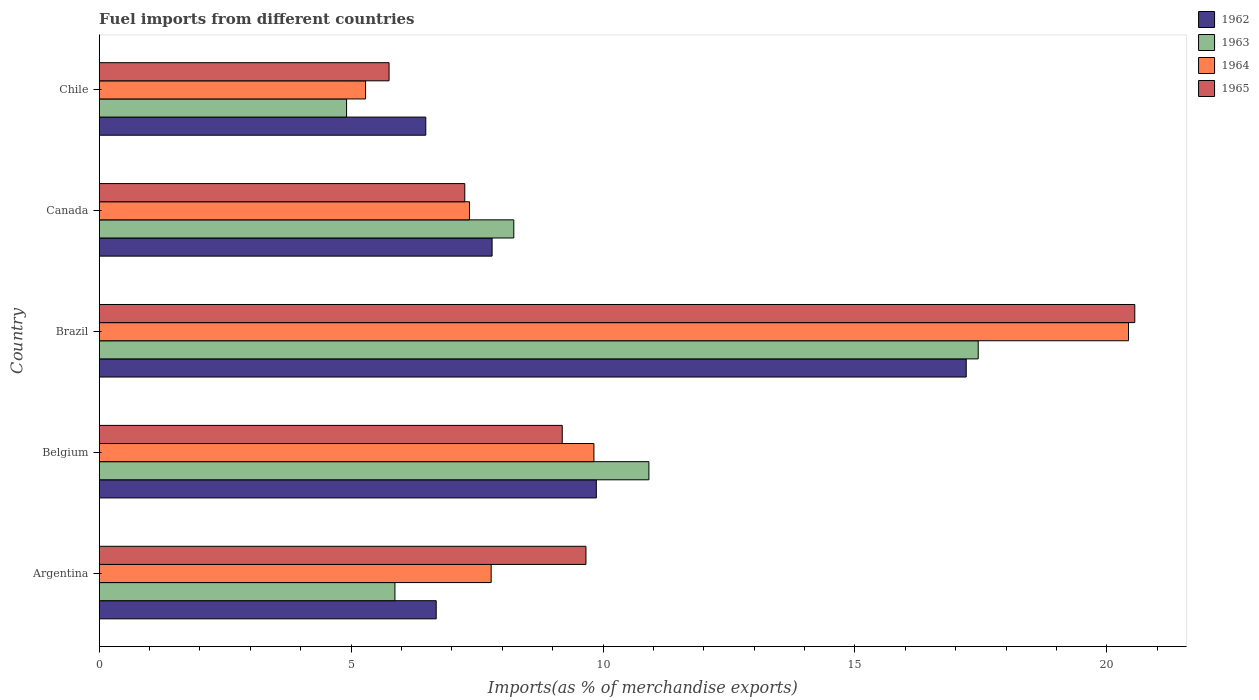How many different coloured bars are there?
Offer a very short reply. 4. How many groups of bars are there?
Offer a terse response. 5. How many bars are there on the 3rd tick from the top?
Provide a succinct answer. 4. How many bars are there on the 4th tick from the bottom?
Your answer should be compact. 4. What is the percentage of imports to different countries in 1965 in Argentina?
Provide a short and direct response. 9.66. Across all countries, what is the maximum percentage of imports to different countries in 1964?
Ensure brevity in your answer.  20.43. Across all countries, what is the minimum percentage of imports to different countries in 1962?
Provide a succinct answer. 6.48. What is the total percentage of imports to different countries in 1963 in the graph?
Your answer should be compact. 47.37. What is the difference between the percentage of imports to different countries in 1962 in Belgium and that in Chile?
Provide a short and direct response. 3.39. What is the difference between the percentage of imports to different countries in 1962 in Argentina and the percentage of imports to different countries in 1963 in Brazil?
Offer a very short reply. -10.76. What is the average percentage of imports to different countries in 1963 per country?
Offer a terse response. 9.47. What is the difference between the percentage of imports to different countries in 1964 and percentage of imports to different countries in 1963 in Chile?
Offer a very short reply. 0.38. In how many countries, is the percentage of imports to different countries in 1965 greater than 12 %?
Ensure brevity in your answer.  1. What is the ratio of the percentage of imports to different countries in 1964 in Belgium to that in Brazil?
Your response must be concise. 0.48. Is the percentage of imports to different countries in 1962 in Brazil less than that in Canada?
Ensure brevity in your answer.  No. Is the difference between the percentage of imports to different countries in 1964 in Argentina and Chile greater than the difference between the percentage of imports to different countries in 1963 in Argentina and Chile?
Ensure brevity in your answer.  Yes. What is the difference between the highest and the second highest percentage of imports to different countries in 1964?
Your response must be concise. 10.61. What is the difference between the highest and the lowest percentage of imports to different countries in 1964?
Offer a very short reply. 15.14. Is it the case that in every country, the sum of the percentage of imports to different countries in 1963 and percentage of imports to different countries in 1965 is greater than the sum of percentage of imports to different countries in 1964 and percentage of imports to different countries in 1962?
Offer a very short reply. No. What does the 3rd bar from the bottom in Belgium represents?
Provide a succinct answer. 1964. Is it the case that in every country, the sum of the percentage of imports to different countries in 1964 and percentage of imports to different countries in 1962 is greater than the percentage of imports to different countries in 1963?
Provide a succinct answer. Yes. How many bars are there?
Give a very brief answer. 20. Are all the bars in the graph horizontal?
Your answer should be compact. Yes. How many countries are there in the graph?
Offer a terse response. 5. Does the graph contain grids?
Make the answer very short. No. How many legend labels are there?
Offer a very short reply. 4. What is the title of the graph?
Make the answer very short. Fuel imports from different countries. What is the label or title of the X-axis?
Your answer should be very brief. Imports(as % of merchandise exports). What is the Imports(as % of merchandise exports) in 1962 in Argentina?
Offer a very short reply. 6.69. What is the Imports(as % of merchandise exports) in 1963 in Argentina?
Offer a very short reply. 5.87. What is the Imports(as % of merchandise exports) in 1964 in Argentina?
Your response must be concise. 7.78. What is the Imports(as % of merchandise exports) of 1965 in Argentina?
Your response must be concise. 9.66. What is the Imports(as % of merchandise exports) in 1962 in Belgium?
Your response must be concise. 9.87. What is the Imports(as % of merchandise exports) in 1963 in Belgium?
Keep it short and to the point. 10.91. What is the Imports(as % of merchandise exports) of 1964 in Belgium?
Make the answer very short. 9.82. What is the Imports(as % of merchandise exports) in 1965 in Belgium?
Provide a succinct answer. 9.19. What is the Imports(as % of merchandise exports) of 1962 in Brazil?
Provide a short and direct response. 17.21. What is the Imports(as % of merchandise exports) in 1963 in Brazil?
Your answer should be very brief. 17.45. What is the Imports(as % of merchandise exports) in 1964 in Brazil?
Offer a terse response. 20.43. What is the Imports(as % of merchandise exports) in 1965 in Brazil?
Provide a succinct answer. 20.55. What is the Imports(as % of merchandise exports) in 1962 in Canada?
Ensure brevity in your answer.  7.8. What is the Imports(as % of merchandise exports) in 1963 in Canada?
Offer a terse response. 8.23. What is the Imports(as % of merchandise exports) in 1964 in Canada?
Your answer should be very brief. 7.35. What is the Imports(as % of merchandise exports) in 1965 in Canada?
Offer a terse response. 7.26. What is the Imports(as % of merchandise exports) of 1962 in Chile?
Give a very brief answer. 6.48. What is the Imports(as % of merchandise exports) of 1963 in Chile?
Offer a terse response. 4.91. What is the Imports(as % of merchandise exports) in 1964 in Chile?
Offer a very short reply. 5.29. What is the Imports(as % of merchandise exports) of 1965 in Chile?
Make the answer very short. 5.75. Across all countries, what is the maximum Imports(as % of merchandise exports) of 1962?
Your answer should be compact. 17.21. Across all countries, what is the maximum Imports(as % of merchandise exports) in 1963?
Keep it short and to the point. 17.45. Across all countries, what is the maximum Imports(as % of merchandise exports) in 1964?
Provide a succinct answer. 20.43. Across all countries, what is the maximum Imports(as % of merchandise exports) of 1965?
Your answer should be compact. 20.55. Across all countries, what is the minimum Imports(as % of merchandise exports) in 1962?
Keep it short and to the point. 6.48. Across all countries, what is the minimum Imports(as % of merchandise exports) of 1963?
Provide a succinct answer. 4.91. Across all countries, what is the minimum Imports(as % of merchandise exports) in 1964?
Your answer should be very brief. 5.29. Across all countries, what is the minimum Imports(as % of merchandise exports) in 1965?
Keep it short and to the point. 5.75. What is the total Imports(as % of merchandise exports) in 1962 in the graph?
Give a very brief answer. 48.04. What is the total Imports(as % of merchandise exports) in 1963 in the graph?
Offer a terse response. 47.37. What is the total Imports(as % of merchandise exports) in 1964 in the graph?
Give a very brief answer. 50.66. What is the total Imports(as % of merchandise exports) in 1965 in the graph?
Offer a terse response. 52.41. What is the difference between the Imports(as % of merchandise exports) of 1962 in Argentina and that in Belgium?
Give a very brief answer. -3.18. What is the difference between the Imports(as % of merchandise exports) of 1963 in Argentina and that in Belgium?
Provide a succinct answer. -5.04. What is the difference between the Imports(as % of merchandise exports) of 1964 in Argentina and that in Belgium?
Offer a terse response. -2.04. What is the difference between the Imports(as % of merchandise exports) in 1965 in Argentina and that in Belgium?
Your answer should be very brief. 0.47. What is the difference between the Imports(as % of merchandise exports) in 1962 in Argentina and that in Brazil?
Make the answer very short. -10.52. What is the difference between the Imports(as % of merchandise exports) of 1963 in Argentina and that in Brazil?
Provide a succinct answer. -11.58. What is the difference between the Imports(as % of merchandise exports) in 1964 in Argentina and that in Brazil?
Ensure brevity in your answer.  -12.65. What is the difference between the Imports(as % of merchandise exports) in 1965 in Argentina and that in Brazil?
Provide a short and direct response. -10.89. What is the difference between the Imports(as % of merchandise exports) of 1962 in Argentina and that in Canada?
Make the answer very short. -1.11. What is the difference between the Imports(as % of merchandise exports) of 1963 in Argentina and that in Canada?
Offer a very short reply. -2.36. What is the difference between the Imports(as % of merchandise exports) in 1964 in Argentina and that in Canada?
Your answer should be compact. 0.43. What is the difference between the Imports(as % of merchandise exports) of 1965 in Argentina and that in Canada?
Make the answer very short. 2.4. What is the difference between the Imports(as % of merchandise exports) in 1962 in Argentina and that in Chile?
Give a very brief answer. 0.21. What is the difference between the Imports(as % of merchandise exports) of 1963 in Argentina and that in Chile?
Keep it short and to the point. 0.96. What is the difference between the Imports(as % of merchandise exports) of 1964 in Argentina and that in Chile?
Your answer should be compact. 2.49. What is the difference between the Imports(as % of merchandise exports) of 1965 in Argentina and that in Chile?
Ensure brevity in your answer.  3.91. What is the difference between the Imports(as % of merchandise exports) in 1962 in Belgium and that in Brazil?
Give a very brief answer. -7.34. What is the difference between the Imports(as % of merchandise exports) in 1963 in Belgium and that in Brazil?
Provide a succinct answer. -6.54. What is the difference between the Imports(as % of merchandise exports) of 1964 in Belgium and that in Brazil?
Ensure brevity in your answer.  -10.61. What is the difference between the Imports(as % of merchandise exports) in 1965 in Belgium and that in Brazil?
Offer a very short reply. -11.36. What is the difference between the Imports(as % of merchandise exports) of 1962 in Belgium and that in Canada?
Give a very brief answer. 2.07. What is the difference between the Imports(as % of merchandise exports) of 1963 in Belgium and that in Canada?
Keep it short and to the point. 2.68. What is the difference between the Imports(as % of merchandise exports) of 1964 in Belgium and that in Canada?
Keep it short and to the point. 2.47. What is the difference between the Imports(as % of merchandise exports) of 1965 in Belgium and that in Canada?
Provide a succinct answer. 1.93. What is the difference between the Imports(as % of merchandise exports) of 1962 in Belgium and that in Chile?
Ensure brevity in your answer.  3.39. What is the difference between the Imports(as % of merchandise exports) in 1963 in Belgium and that in Chile?
Make the answer very short. 6. What is the difference between the Imports(as % of merchandise exports) of 1964 in Belgium and that in Chile?
Your answer should be compact. 4.53. What is the difference between the Imports(as % of merchandise exports) in 1965 in Belgium and that in Chile?
Provide a short and direct response. 3.44. What is the difference between the Imports(as % of merchandise exports) of 1962 in Brazil and that in Canada?
Make the answer very short. 9.41. What is the difference between the Imports(as % of merchandise exports) in 1963 in Brazil and that in Canada?
Ensure brevity in your answer.  9.22. What is the difference between the Imports(as % of merchandise exports) in 1964 in Brazil and that in Canada?
Keep it short and to the point. 13.08. What is the difference between the Imports(as % of merchandise exports) in 1965 in Brazil and that in Canada?
Offer a very short reply. 13.3. What is the difference between the Imports(as % of merchandise exports) in 1962 in Brazil and that in Chile?
Ensure brevity in your answer.  10.73. What is the difference between the Imports(as % of merchandise exports) in 1963 in Brazil and that in Chile?
Make the answer very short. 12.54. What is the difference between the Imports(as % of merchandise exports) in 1964 in Brazil and that in Chile?
Your answer should be very brief. 15.14. What is the difference between the Imports(as % of merchandise exports) in 1965 in Brazil and that in Chile?
Offer a terse response. 14.8. What is the difference between the Imports(as % of merchandise exports) in 1962 in Canada and that in Chile?
Offer a terse response. 1.32. What is the difference between the Imports(as % of merchandise exports) in 1963 in Canada and that in Chile?
Your answer should be compact. 3.32. What is the difference between the Imports(as % of merchandise exports) of 1964 in Canada and that in Chile?
Offer a very short reply. 2.06. What is the difference between the Imports(as % of merchandise exports) in 1965 in Canada and that in Chile?
Provide a short and direct response. 1.5. What is the difference between the Imports(as % of merchandise exports) of 1962 in Argentina and the Imports(as % of merchandise exports) of 1963 in Belgium?
Keep it short and to the point. -4.22. What is the difference between the Imports(as % of merchandise exports) in 1962 in Argentina and the Imports(as % of merchandise exports) in 1964 in Belgium?
Make the answer very short. -3.13. What is the difference between the Imports(as % of merchandise exports) in 1962 in Argentina and the Imports(as % of merchandise exports) in 1965 in Belgium?
Your answer should be very brief. -2.5. What is the difference between the Imports(as % of merchandise exports) of 1963 in Argentina and the Imports(as % of merchandise exports) of 1964 in Belgium?
Provide a succinct answer. -3.95. What is the difference between the Imports(as % of merchandise exports) of 1963 in Argentina and the Imports(as % of merchandise exports) of 1965 in Belgium?
Keep it short and to the point. -3.32. What is the difference between the Imports(as % of merchandise exports) in 1964 in Argentina and the Imports(as % of merchandise exports) in 1965 in Belgium?
Keep it short and to the point. -1.41. What is the difference between the Imports(as % of merchandise exports) in 1962 in Argentina and the Imports(as % of merchandise exports) in 1963 in Brazil?
Offer a terse response. -10.76. What is the difference between the Imports(as % of merchandise exports) in 1962 in Argentina and the Imports(as % of merchandise exports) in 1964 in Brazil?
Your answer should be compact. -13.74. What is the difference between the Imports(as % of merchandise exports) in 1962 in Argentina and the Imports(as % of merchandise exports) in 1965 in Brazil?
Provide a short and direct response. -13.87. What is the difference between the Imports(as % of merchandise exports) in 1963 in Argentina and the Imports(as % of merchandise exports) in 1964 in Brazil?
Your answer should be compact. -14.56. What is the difference between the Imports(as % of merchandise exports) of 1963 in Argentina and the Imports(as % of merchandise exports) of 1965 in Brazil?
Your answer should be compact. -14.68. What is the difference between the Imports(as % of merchandise exports) of 1964 in Argentina and the Imports(as % of merchandise exports) of 1965 in Brazil?
Offer a terse response. -12.77. What is the difference between the Imports(as % of merchandise exports) in 1962 in Argentina and the Imports(as % of merchandise exports) in 1963 in Canada?
Give a very brief answer. -1.54. What is the difference between the Imports(as % of merchandise exports) of 1962 in Argentina and the Imports(as % of merchandise exports) of 1964 in Canada?
Ensure brevity in your answer.  -0.66. What is the difference between the Imports(as % of merchandise exports) of 1962 in Argentina and the Imports(as % of merchandise exports) of 1965 in Canada?
Give a very brief answer. -0.57. What is the difference between the Imports(as % of merchandise exports) in 1963 in Argentina and the Imports(as % of merchandise exports) in 1964 in Canada?
Make the answer very short. -1.48. What is the difference between the Imports(as % of merchandise exports) of 1963 in Argentina and the Imports(as % of merchandise exports) of 1965 in Canada?
Your answer should be very brief. -1.39. What is the difference between the Imports(as % of merchandise exports) of 1964 in Argentina and the Imports(as % of merchandise exports) of 1965 in Canada?
Your answer should be compact. 0.52. What is the difference between the Imports(as % of merchandise exports) in 1962 in Argentina and the Imports(as % of merchandise exports) in 1963 in Chile?
Provide a succinct answer. 1.78. What is the difference between the Imports(as % of merchandise exports) in 1962 in Argentina and the Imports(as % of merchandise exports) in 1964 in Chile?
Your answer should be very brief. 1.4. What is the difference between the Imports(as % of merchandise exports) of 1962 in Argentina and the Imports(as % of merchandise exports) of 1965 in Chile?
Your response must be concise. 0.94. What is the difference between the Imports(as % of merchandise exports) of 1963 in Argentina and the Imports(as % of merchandise exports) of 1964 in Chile?
Offer a very short reply. 0.58. What is the difference between the Imports(as % of merchandise exports) in 1963 in Argentina and the Imports(as % of merchandise exports) in 1965 in Chile?
Provide a succinct answer. 0.12. What is the difference between the Imports(as % of merchandise exports) in 1964 in Argentina and the Imports(as % of merchandise exports) in 1965 in Chile?
Provide a succinct answer. 2.03. What is the difference between the Imports(as % of merchandise exports) in 1962 in Belgium and the Imports(as % of merchandise exports) in 1963 in Brazil?
Provide a succinct answer. -7.58. What is the difference between the Imports(as % of merchandise exports) of 1962 in Belgium and the Imports(as % of merchandise exports) of 1964 in Brazil?
Make the answer very short. -10.56. What is the difference between the Imports(as % of merchandise exports) in 1962 in Belgium and the Imports(as % of merchandise exports) in 1965 in Brazil?
Offer a terse response. -10.69. What is the difference between the Imports(as % of merchandise exports) in 1963 in Belgium and the Imports(as % of merchandise exports) in 1964 in Brazil?
Ensure brevity in your answer.  -9.52. What is the difference between the Imports(as % of merchandise exports) in 1963 in Belgium and the Imports(as % of merchandise exports) in 1965 in Brazil?
Offer a very short reply. -9.64. What is the difference between the Imports(as % of merchandise exports) of 1964 in Belgium and the Imports(as % of merchandise exports) of 1965 in Brazil?
Ensure brevity in your answer.  -10.74. What is the difference between the Imports(as % of merchandise exports) of 1962 in Belgium and the Imports(as % of merchandise exports) of 1963 in Canada?
Give a very brief answer. 1.64. What is the difference between the Imports(as % of merchandise exports) of 1962 in Belgium and the Imports(as % of merchandise exports) of 1964 in Canada?
Keep it short and to the point. 2.52. What is the difference between the Imports(as % of merchandise exports) in 1962 in Belgium and the Imports(as % of merchandise exports) in 1965 in Canada?
Offer a very short reply. 2.61. What is the difference between the Imports(as % of merchandise exports) of 1963 in Belgium and the Imports(as % of merchandise exports) of 1964 in Canada?
Your answer should be compact. 3.56. What is the difference between the Imports(as % of merchandise exports) of 1963 in Belgium and the Imports(as % of merchandise exports) of 1965 in Canada?
Your response must be concise. 3.65. What is the difference between the Imports(as % of merchandise exports) in 1964 in Belgium and the Imports(as % of merchandise exports) in 1965 in Canada?
Your response must be concise. 2.56. What is the difference between the Imports(as % of merchandise exports) in 1962 in Belgium and the Imports(as % of merchandise exports) in 1963 in Chile?
Offer a terse response. 4.96. What is the difference between the Imports(as % of merchandise exports) of 1962 in Belgium and the Imports(as % of merchandise exports) of 1964 in Chile?
Provide a short and direct response. 4.58. What is the difference between the Imports(as % of merchandise exports) of 1962 in Belgium and the Imports(as % of merchandise exports) of 1965 in Chile?
Your answer should be compact. 4.11. What is the difference between the Imports(as % of merchandise exports) of 1963 in Belgium and the Imports(as % of merchandise exports) of 1964 in Chile?
Offer a very short reply. 5.62. What is the difference between the Imports(as % of merchandise exports) in 1963 in Belgium and the Imports(as % of merchandise exports) in 1965 in Chile?
Provide a succinct answer. 5.16. What is the difference between the Imports(as % of merchandise exports) in 1964 in Belgium and the Imports(as % of merchandise exports) in 1965 in Chile?
Your answer should be very brief. 4.07. What is the difference between the Imports(as % of merchandise exports) in 1962 in Brazil and the Imports(as % of merchandise exports) in 1963 in Canada?
Keep it short and to the point. 8.98. What is the difference between the Imports(as % of merchandise exports) of 1962 in Brazil and the Imports(as % of merchandise exports) of 1964 in Canada?
Ensure brevity in your answer.  9.86. What is the difference between the Imports(as % of merchandise exports) in 1962 in Brazil and the Imports(as % of merchandise exports) in 1965 in Canada?
Provide a short and direct response. 9.95. What is the difference between the Imports(as % of merchandise exports) of 1963 in Brazil and the Imports(as % of merchandise exports) of 1964 in Canada?
Provide a succinct answer. 10.1. What is the difference between the Imports(as % of merchandise exports) in 1963 in Brazil and the Imports(as % of merchandise exports) in 1965 in Canada?
Your answer should be compact. 10.19. What is the difference between the Imports(as % of merchandise exports) of 1964 in Brazil and the Imports(as % of merchandise exports) of 1965 in Canada?
Make the answer very short. 13.17. What is the difference between the Imports(as % of merchandise exports) of 1962 in Brazil and the Imports(as % of merchandise exports) of 1963 in Chile?
Offer a terse response. 12.3. What is the difference between the Imports(as % of merchandise exports) of 1962 in Brazil and the Imports(as % of merchandise exports) of 1964 in Chile?
Ensure brevity in your answer.  11.92. What is the difference between the Imports(as % of merchandise exports) in 1962 in Brazil and the Imports(as % of merchandise exports) in 1965 in Chile?
Your answer should be compact. 11.46. What is the difference between the Imports(as % of merchandise exports) in 1963 in Brazil and the Imports(as % of merchandise exports) in 1964 in Chile?
Ensure brevity in your answer.  12.16. What is the difference between the Imports(as % of merchandise exports) of 1963 in Brazil and the Imports(as % of merchandise exports) of 1965 in Chile?
Ensure brevity in your answer.  11.69. What is the difference between the Imports(as % of merchandise exports) of 1964 in Brazil and the Imports(as % of merchandise exports) of 1965 in Chile?
Your answer should be compact. 14.68. What is the difference between the Imports(as % of merchandise exports) in 1962 in Canada and the Imports(as % of merchandise exports) in 1963 in Chile?
Your answer should be very brief. 2.89. What is the difference between the Imports(as % of merchandise exports) in 1962 in Canada and the Imports(as % of merchandise exports) in 1964 in Chile?
Provide a succinct answer. 2.51. What is the difference between the Imports(as % of merchandise exports) in 1962 in Canada and the Imports(as % of merchandise exports) in 1965 in Chile?
Ensure brevity in your answer.  2.04. What is the difference between the Imports(as % of merchandise exports) of 1963 in Canada and the Imports(as % of merchandise exports) of 1964 in Chile?
Provide a short and direct response. 2.94. What is the difference between the Imports(as % of merchandise exports) in 1963 in Canada and the Imports(as % of merchandise exports) in 1965 in Chile?
Your response must be concise. 2.48. What is the difference between the Imports(as % of merchandise exports) in 1964 in Canada and the Imports(as % of merchandise exports) in 1965 in Chile?
Your response must be concise. 1.6. What is the average Imports(as % of merchandise exports) in 1962 per country?
Your answer should be very brief. 9.61. What is the average Imports(as % of merchandise exports) in 1963 per country?
Offer a terse response. 9.47. What is the average Imports(as % of merchandise exports) of 1964 per country?
Provide a short and direct response. 10.13. What is the average Imports(as % of merchandise exports) of 1965 per country?
Your answer should be very brief. 10.48. What is the difference between the Imports(as % of merchandise exports) in 1962 and Imports(as % of merchandise exports) in 1963 in Argentina?
Your response must be concise. 0.82. What is the difference between the Imports(as % of merchandise exports) in 1962 and Imports(as % of merchandise exports) in 1964 in Argentina?
Give a very brief answer. -1.09. What is the difference between the Imports(as % of merchandise exports) of 1962 and Imports(as % of merchandise exports) of 1965 in Argentina?
Your response must be concise. -2.97. What is the difference between the Imports(as % of merchandise exports) of 1963 and Imports(as % of merchandise exports) of 1964 in Argentina?
Offer a very short reply. -1.91. What is the difference between the Imports(as % of merchandise exports) in 1963 and Imports(as % of merchandise exports) in 1965 in Argentina?
Provide a succinct answer. -3.79. What is the difference between the Imports(as % of merchandise exports) in 1964 and Imports(as % of merchandise exports) in 1965 in Argentina?
Your response must be concise. -1.88. What is the difference between the Imports(as % of merchandise exports) in 1962 and Imports(as % of merchandise exports) in 1963 in Belgium?
Your answer should be very brief. -1.04. What is the difference between the Imports(as % of merchandise exports) in 1962 and Imports(as % of merchandise exports) in 1964 in Belgium?
Ensure brevity in your answer.  0.05. What is the difference between the Imports(as % of merchandise exports) of 1962 and Imports(as % of merchandise exports) of 1965 in Belgium?
Give a very brief answer. 0.68. What is the difference between the Imports(as % of merchandise exports) in 1963 and Imports(as % of merchandise exports) in 1964 in Belgium?
Ensure brevity in your answer.  1.09. What is the difference between the Imports(as % of merchandise exports) of 1963 and Imports(as % of merchandise exports) of 1965 in Belgium?
Give a very brief answer. 1.72. What is the difference between the Imports(as % of merchandise exports) in 1964 and Imports(as % of merchandise exports) in 1965 in Belgium?
Your answer should be very brief. 0.63. What is the difference between the Imports(as % of merchandise exports) in 1962 and Imports(as % of merchandise exports) in 1963 in Brazil?
Your answer should be compact. -0.24. What is the difference between the Imports(as % of merchandise exports) of 1962 and Imports(as % of merchandise exports) of 1964 in Brazil?
Offer a terse response. -3.22. What is the difference between the Imports(as % of merchandise exports) in 1962 and Imports(as % of merchandise exports) in 1965 in Brazil?
Your answer should be compact. -3.35. What is the difference between the Imports(as % of merchandise exports) of 1963 and Imports(as % of merchandise exports) of 1964 in Brazil?
Your answer should be compact. -2.98. What is the difference between the Imports(as % of merchandise exports) of 1963 and Imports(as % of merchandise exports) of 1965 in Brazil?
Provide a short and direct response. -3.11. What is the difference between the Imports(as % of merchandise exports) in 1964 and Imports(as % of merchandise exports) in 1965 in Brazil?
Make the answer very short. -0.12. What is the difference between the Imports(as % of merchandise exports) of 1962 and Imports(as % of merchandise exports) of 1963 in Canada?
Make the answer very short. -0.43. What is the difference between the Imports(as % of merchandise exports) in 1962 and Imports(as % of merchandise exports) in 1964 in Canada?
Your answer should be very brief. 0.45. What is the difference between the Imports(as % of merchandise exports) of 1962 and Imports(as % of merchandise exports) of 1965 in Canada?
Offer a terse response. 0.54. What is the difference between the Imports(as % of merchandise exports) in 1963 and Imports(as % of merchandise exports) in 1964 in Canada?
Keep it short and to the point. 0.88. What is the difference between the Imports(as % of merchandise exports) in 1963 and Imports(as % of merchandise exports) in 1965 in Canada?
Give a very brief answer. 0.97. What is the difference between the Imports(as % of merchandise exports) of 1964 and Imports(as % of merchandise exports) of 1965 in Canada?
Give a very brief answer. 0.09. What is the difference between the Imports(as % of merchandise exports) of 1962 and Imports(as % of merchandise exports) of 1963 in Chile?
Your response must be concise. 1.57. What is the difference between the Imports(as % of merchandise exports) in 1962 and Imports(as % of merchandise exports) in 1964 in Chile?
Offer a terse response. 1.19. What is the difference between the Imports(as % of merchandise exports) in 1962 and Imports(as % of merchandise exports) in 1965 in Chile?
Offer a very short reply. 0.73. What is the difference between the Imports(as % of merchandise exports) of 1963 and Imports(as % of merchandise exports) of 1964 in Chile?
Make the answer very short. -0.38. What is the difference between the Imports(as % of merchandise exports) of 1963 and Imports(as % of merchandise exports) of 1965 in Chile?
Make the answer very short. -0.84. What is the difference between the Imports(as % of merchandise exports) in 1964 and Imports(as % of merchandise exports) in 1965 in Chile?
Give a very brief answer. -0.47. What is the ratio of the Imports(as % of merchandise exports) in 1962 in Argentina to that in Belgium?
Your answer should be compact. 0.68. What is the ratio of the Imports(as % of merchandise exports) in 1963 in Argentina to that in Belgium?
Make the answer very short. 0.54. What is the ratio of the Imports(as % of merchandise exports) of 1964 in Argentina to that in Belgium?
Make the answer very short. 0.79. What is the ratio of the Imports(as % of merchandise exports) of 1965 in Argentina to that in Belgium?
Your response must be concise. 1.05. What is the ratio of the Imports(as % of merchandise exports) in 1962 in Argentina to that in Brazil?
Your answer should be very brief. 0.39. What is the ratio of the Imports(as % of merchandise exports) of 1963 in Argentina to that in Brazil?
Offer a very short reply. 0.34. What is the ratio of the Imports(as % of merchandise exports) in 1964 in Argentina to that in Brazil?
Provide a succinct answer. 0.38. What is the ratio of the Imports(as % of merchandise exports) of 1965 in Argentina to that in Brazil?
Offer a terse response. 0.47. What is the ratio of the Imports(as % of merchandise exports) in 1962 in Argentina to that in Canada?
Keep it short and to the point. 0.86. What is the ratio of the Imports(as % of merchandise exports) of 1963 in Argentina to that in Canada?
Make the answer very short. 0.71. What is the ratio of the Imports(as % of merchandise exports) in 1964 in Argentina to that in Canada?
Ensure brevity in your answer.  1.06. What is the ratio of the Imports(as % of merchandise exports) in 1965 in Argentina to that in Canada?
Make the answer very short. 1.33. What is the ratio of the Imports(as % of merchandise exports) of 1962 in Argentina to that in Chile?
Ensure brevity in your answer.  1.03. What is the ratio of the Imports(as % of merchandise exports) of 1963 in Argentina to that in Chile?
Give a very brief answer. 1.2. What is the ratio of the Imports(as % of merchandise exports) of 1964 in Argentina to that in Chile?
Your answer should be very brief. 1.47. What is the ratio of the Imports(as % of merchandise exports) in 1965 in Argentina to that in Chile?
Your response must be concise. 1.68. What is the ratio of the Imports(as % of merchandise exports) of 1962 in Belgium to that in Brazil?
Your response must be concise. 0.57. What is the ratio of the Imports(as % of merchandise exports) of 1963 in Belgium to that in Brazil?
Your response must be concise. 0.63. What is the ratio of the Imports(as % of merchandise exports) in 1964 in Belgium to that in Brazil?
Provide a short and direct response. 0.48. What is the ratio of the Imports(as % of merchandise exports) in 1965 in Belgium to that in Brazil?
Provide a short and direct response. 0.45. What is the ratio of the Imports(as % of merchandise exports) of 1962 in Belgium to that in Canada?
Offer a very short reply. 1.27. What is the ratio of the Imports(as % of merchandise exports) of 1963 in Belgium to that in Canada?
Your response must be concise. 1.33. What is the ratio of the Imports(as % of merchandise exports) in 1964 in Belgium to that in Canada?
Provide a short and direct response. 1.34. What is the ratio of the Imports(as % of merchandise exports) in 1965 in Belgium to that in Canada?
Your answer should be very brief. 1.27. What is the ratio of the Imports(as % of merchandise exports) in 1962 in Belgium to that in Chile?
Your answer should be very brief. 1.52. What is the ratio of the Imports(as % of merchandise exports) of 1963 in Belgium to that in Chile?
Provide a short and direct response. 2.22. What is the ratio of the Imports(as % of merchandise exports) of 1964 in Belgium to that in Chile?
Provide a succinct answer. 1.86. What is the ratio of the Imports(as % of merchandise exports) of 1965 in Belgium to that in Chile?
Make the answer very short. 1.6. What is the ratio of the Imports(as % of merchandise exports) of 1962 in Brazil to that in Canada?
Keep it short and to the point. 2.21. What is the ratio of the Imports(as % of merchandise exports) of 1963 in Brazil to that in Canada?
Offer a terse response. 2.12. What is the ratio of the Imports(as % of merchandise exports) of 1964 in Brazil to that in Canada?
Provide a succinct answer. 2.78. What is the ratio of the Imports(as % of merchandise exports) in 1965 in Brazil to that in Canada?
Keep it short and to the point. 2.83. What is the ratio of the Imports(as % of merchandise exports) of 1962 in Brazil to that in Chile?
Your answer should be compact. 2.65. What is the ratio of the Imports(as % of merchandise exports) in 1963 in Brazil to that in Chile?
Keep it short and to the point. 3.55. What is the ratio of the Imports(as % of merchandise exports) in 1964 in Brazil to that in Chile?
Offer a terse response. 3.86. What is the ratio of the Imports(as % of merchandise exports) of 1965 in Brazil to that in Chile?
Keep it short and to the point. 3.57. What is the ratio of the Imports(as % of merchandise exports) of 1962 in Canada to that in Chile?
Your answer should be compact. 1.2. What is the ratio of the Imports(as % of merchandise exports) of 1963 in Canada to that in Chile?
Offer a terse response. 1.68. What is the ratio of the Imports(as % of merchandise exports) of 1964 in Canada to that in Chile?
Your response must be concise. 1.39. What is the ratio of the Imports(as % of merchandise exports) in 1965 in Canada to that in Chile?
Keep it short and to the point. 1.26. What is the difference between the highest and the second highest Imports(as % of merchandise exports) of 1962?
Offer a terse response. 7.34. What is the difference between the highest and the second highest Imports(as % of merchandise exports) in 1963?
Provide a succinct answer. 6.54. What is the difference between the highest and the second highest Imports(as % of merchandise exports) in 1964?
Keep it short and to the point. 10.61. What is the difference between the highest and the second highest Imports(as % of merchandise exports) of 1965?
Offer a terse response. 10.89. What is the difference between the highest and the lowest Imports(as % of merchandise exports) in 1962?
Offer a terse response. 10.73. What is the difference between the highest and the lowest Imports(as % of merchandise exports) of 1963?
Your answer should be very brief. 12.54. What is the difference between the highest and the lowest Imports(as % of merchandise exports) in 1964?
Provide a short and direct response. 15.14. What is the difference between the highest and the lowest Imports(as % of merchandise exports) of 1965?
Make the answer very short. 14.8. 